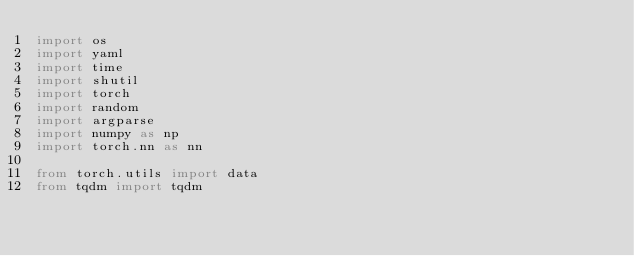Convert code to text. <code><loc_0><loc_0><loc_500><loc_500><_Python_>import os
import yaml
import time
import shutil
import torch
import random
import argparse
import numpy as np
import torch.nn as nn

from torch.utils import data
from tqdm import tqdm
</code> 